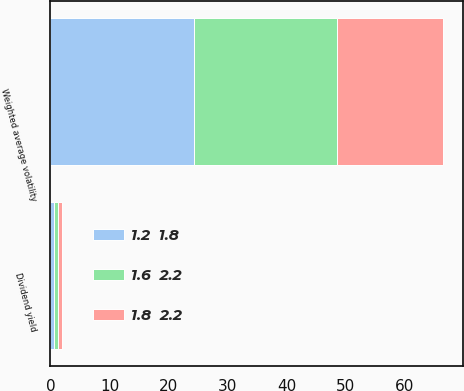Convert chart. <chart><loc_0><loc_0><loc_500><loc_500><stacked_bar_chart><ecel><fcel>Weighted average volatility<fcel>Dividend yield<nl><fcel>1.8  2.2<fcel>17.9<fcel>0.7<nl><fcel>1.2  1.8<fcel>24.3<fcel>0.6<nl><fcel>1.6  2.2<fcel>24.3<fcel>0.6<nl></chart> 